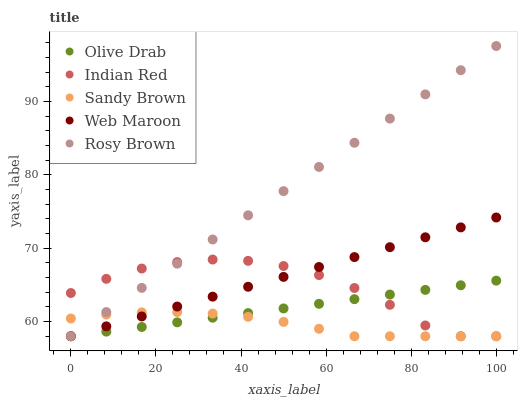Does Sandy Brown have the minimum area under the curve?
Answer yes or no. Yes. Does Rosy Brown have the maximum area under the curve?
Answer yes or no. Yes. Does Rosy Brown have the minimum area under the curve?
Answer yes or no. No. Does Sandy Brown have the maximum area under the curve?
Answer yes or no. No. Is Web Maroon the smoothest?
Answer yes or no. Yes. Is Indian Red the roughest?
Answer yes or no. Yes. Is Rosy Brown the smoothest?
Answer yes or no. No. Is Rosy Brown the roughest?
Answer yes or no. No. Does Web Maroon have the lowest value?
Answer yes or no. Yes. Does Rosy Brown have the highest value?
Answer yes or no. Yes. Does Sandy Brown have the highest value?
Answer yes or no. No. Does Indian Red intersect Web Maroon?
Answer yes or no. Yes. Is Indian Red less than Web Maroon?
Answer yes or no. No. Is Indian Red greater than Web Maroon?
Answer yes or no. No. 